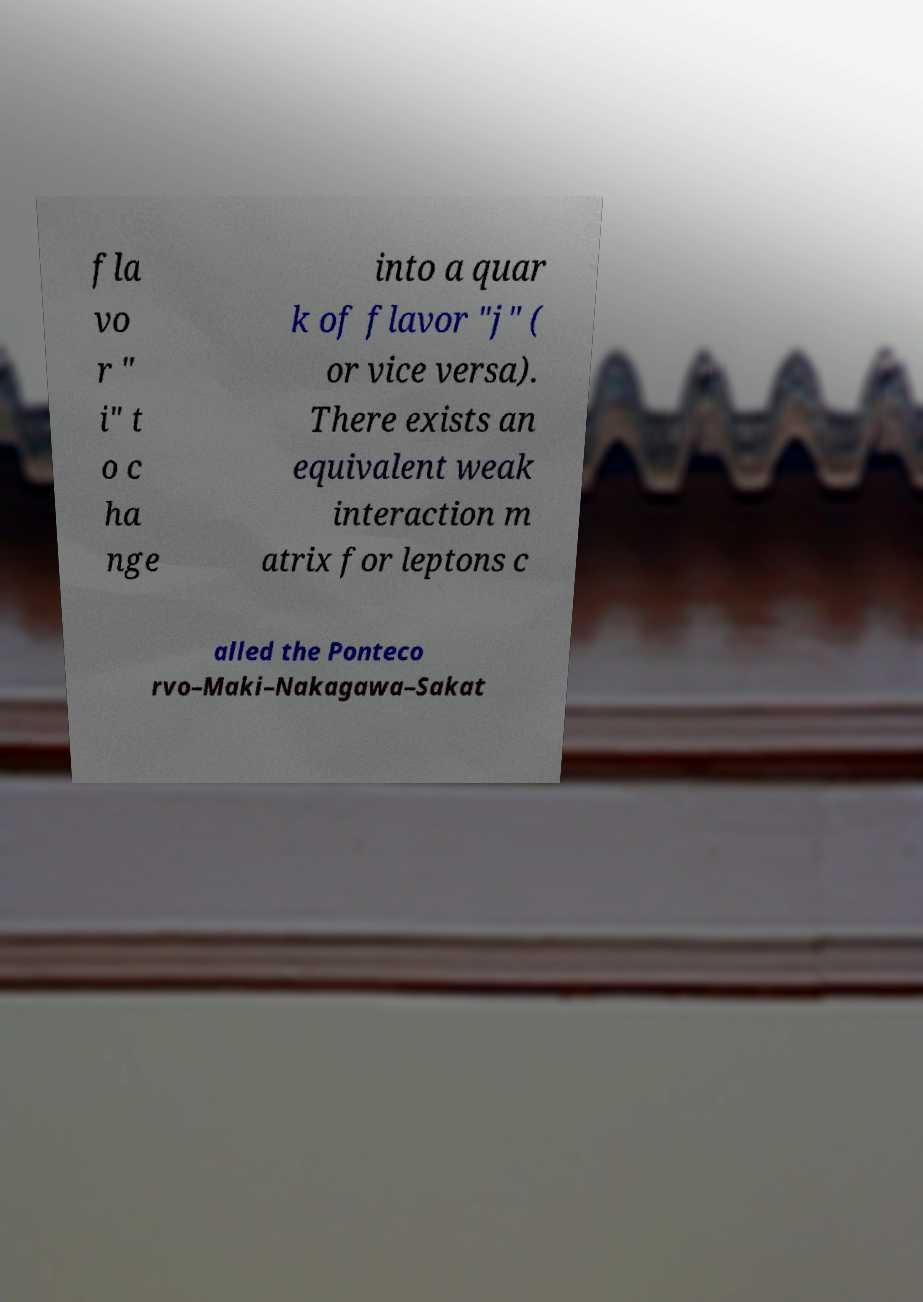Can you read and provide the text displayed in the image?This photo seems to have some interesting text. Can you extract and type it out for me? fla vo r " i" t o c ha nge into a quar k of flavor "j" ( or vice versa). There exists an equivalent weak interaction m atrix for leptons c alled the Ponteco rvo–Maki–Nakagawa–Sakat 